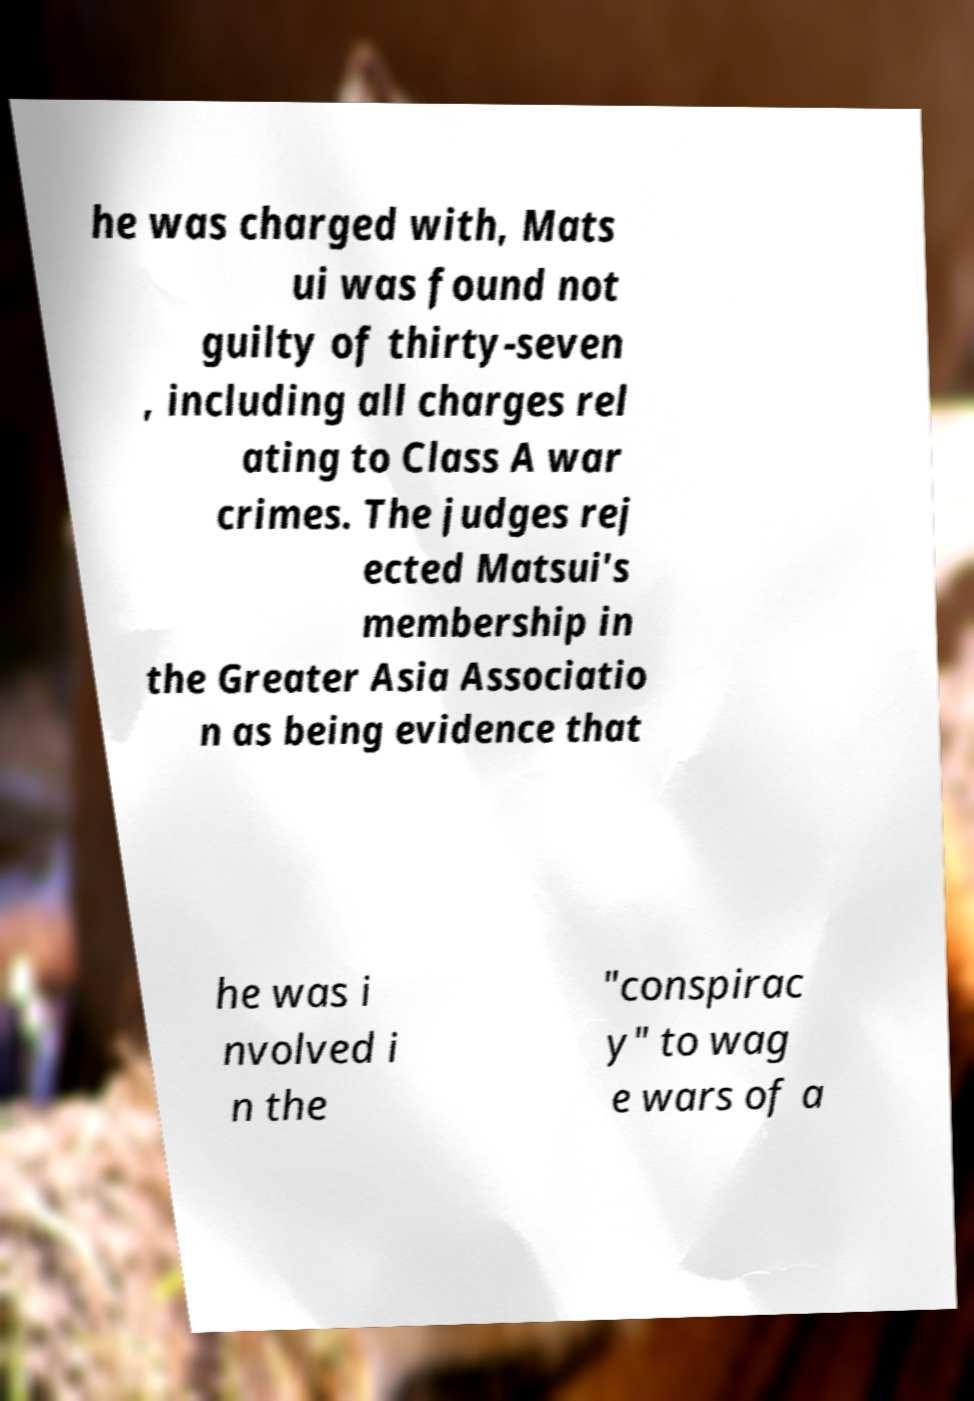Please read and relay the text visible in this image. What does it say? he was charged with, Mats ui was found not guilty of thirty-seven , including all charges rel ating to Class A war crimes. The judges rej ected Matsui's membership in the Greater Asia Associatio n as being evidence that he was i nvolved i n the "conspirac y" to wag e wars of a 